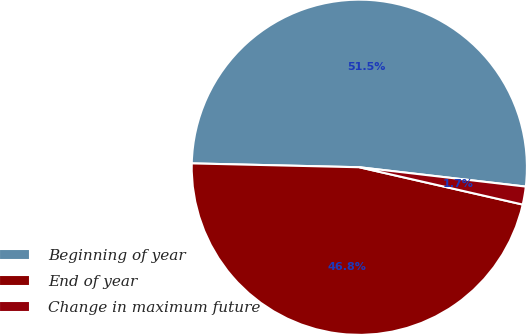Convert chart. <chart><loc_0><loc_0><loc_500><loc_500><pie_chart><fcel>Beginning of year<fcel>End of year<fcel>Change in maximum future<nl><fcel>51.47%<fcel>46.79%<fcel>1.73%<nl></chart> 